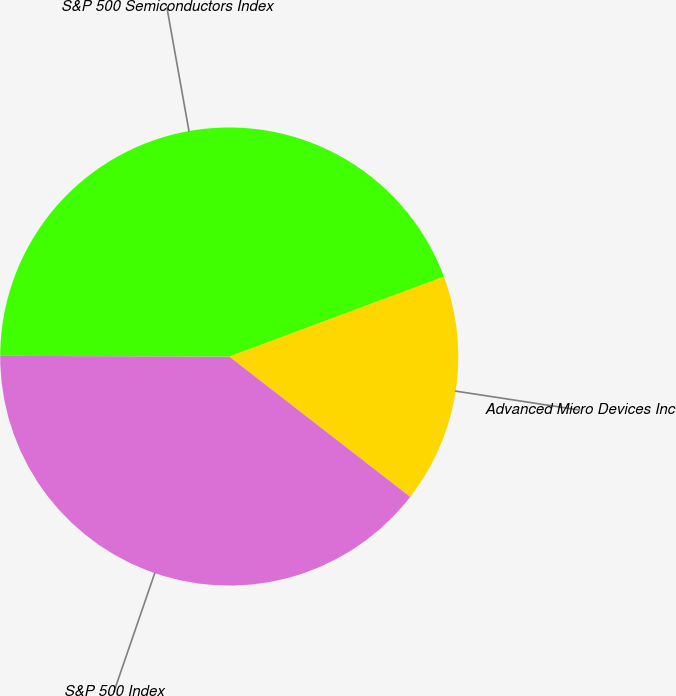Convert chart to OTSL. <chart><loc_0><loc_0><loc_500><loc_500><pie_chart><fcel>Advanced Micro Devices Inc<fcel>S&P 500 Index<fcel>S&P 500 Semiconductors Index<nl><fcel>16.17%<fcel>39.55%<fcel>44.28%<nl></chart> 